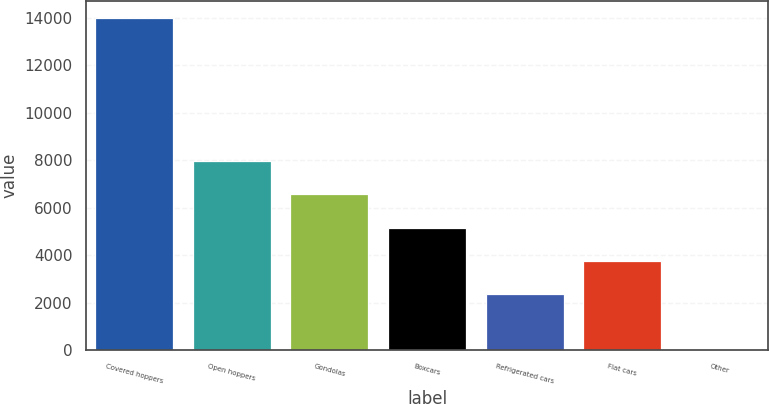Convert chart. <chart><loc_0><loc_0><loc_500><loc_500><bar_chart><fcel>Covered hoppers<fcel>Open hoppers<fcel>Gondolas<fcel>Boxcars<fcel>Refrigerated cars<fcel>Flat cars<fcel>Other<nl><fcel>14001<fcel>7969.2<fcel>6569.9<fcel>5170.6<fcel>2372<fcel>3771.3<fcel>8<nl></chart> 